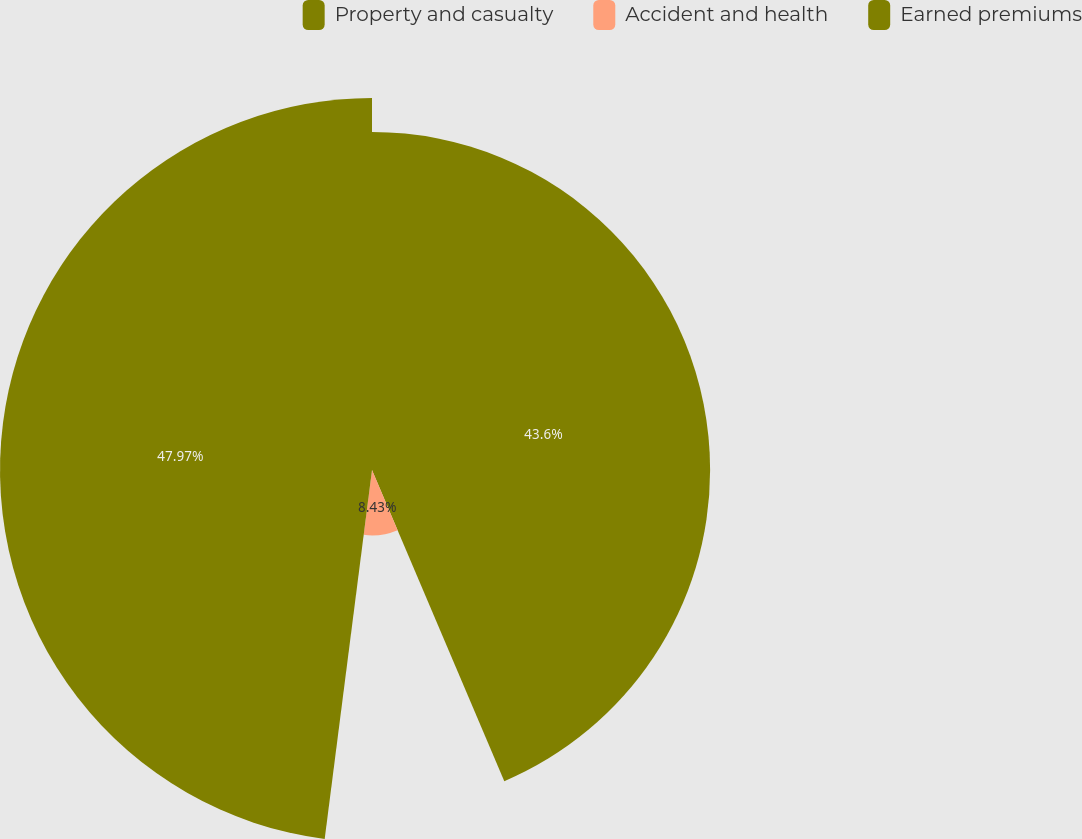<chart> <loc_0><loc_0><loc_500><loc_500><pie_chart><fcel>Property and casualty<fcel>Accident and health<fcel>Earned premiums<nl><fcel>43.6%<fcel>8.43%<fcel>47.97%<nl></chart> 